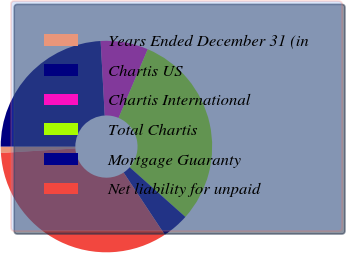Convert chart. <chart><loc_0><loc_0><loc_500><loc_500><pie_chart><fcel>Years Ended December 31 (in<fcel>Chartis US<fcel>Chartis International<fcel>Total Chartis<fcel>Mortgage Guaranty<fcel>Net liability for unpaid<nl><fcel>0.96%<fcel>24.13%<fcel>7.26%<fcel>30.2%<fcel>4.11%<fcel>33.34%<nl></chart> 